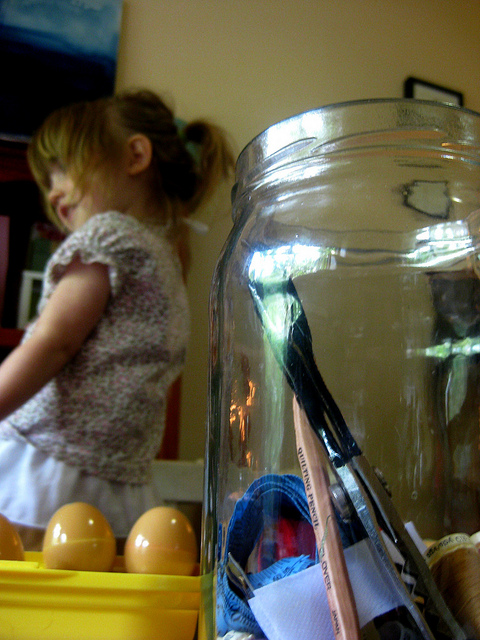What's in the jar in the foreground? The jar in the foreground contains a variety of objects like pens, a brush, and some paper, suggesting it's being used for storage. 